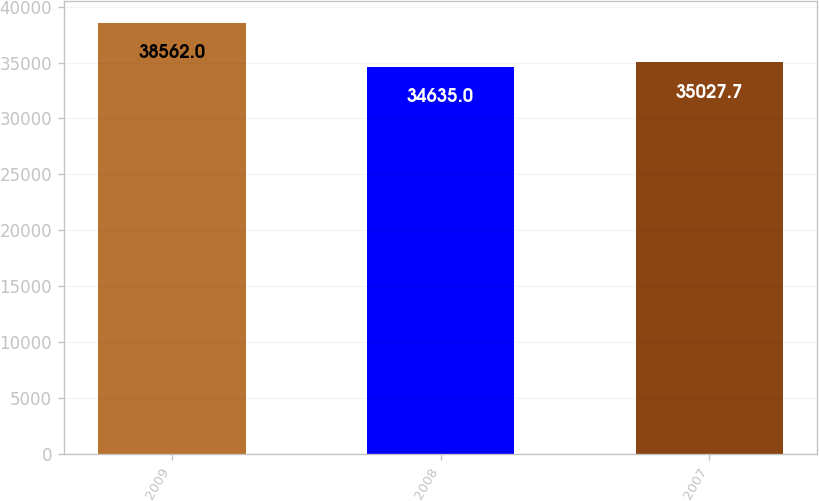<chart> <loc_0><loc_0><loc_500><loc_500><bar_chart><fcel>2009<fcel>2008<fcel>2007<nl><fcel>38562<fcel>34635<fcel>35027.7<nl></chart> 